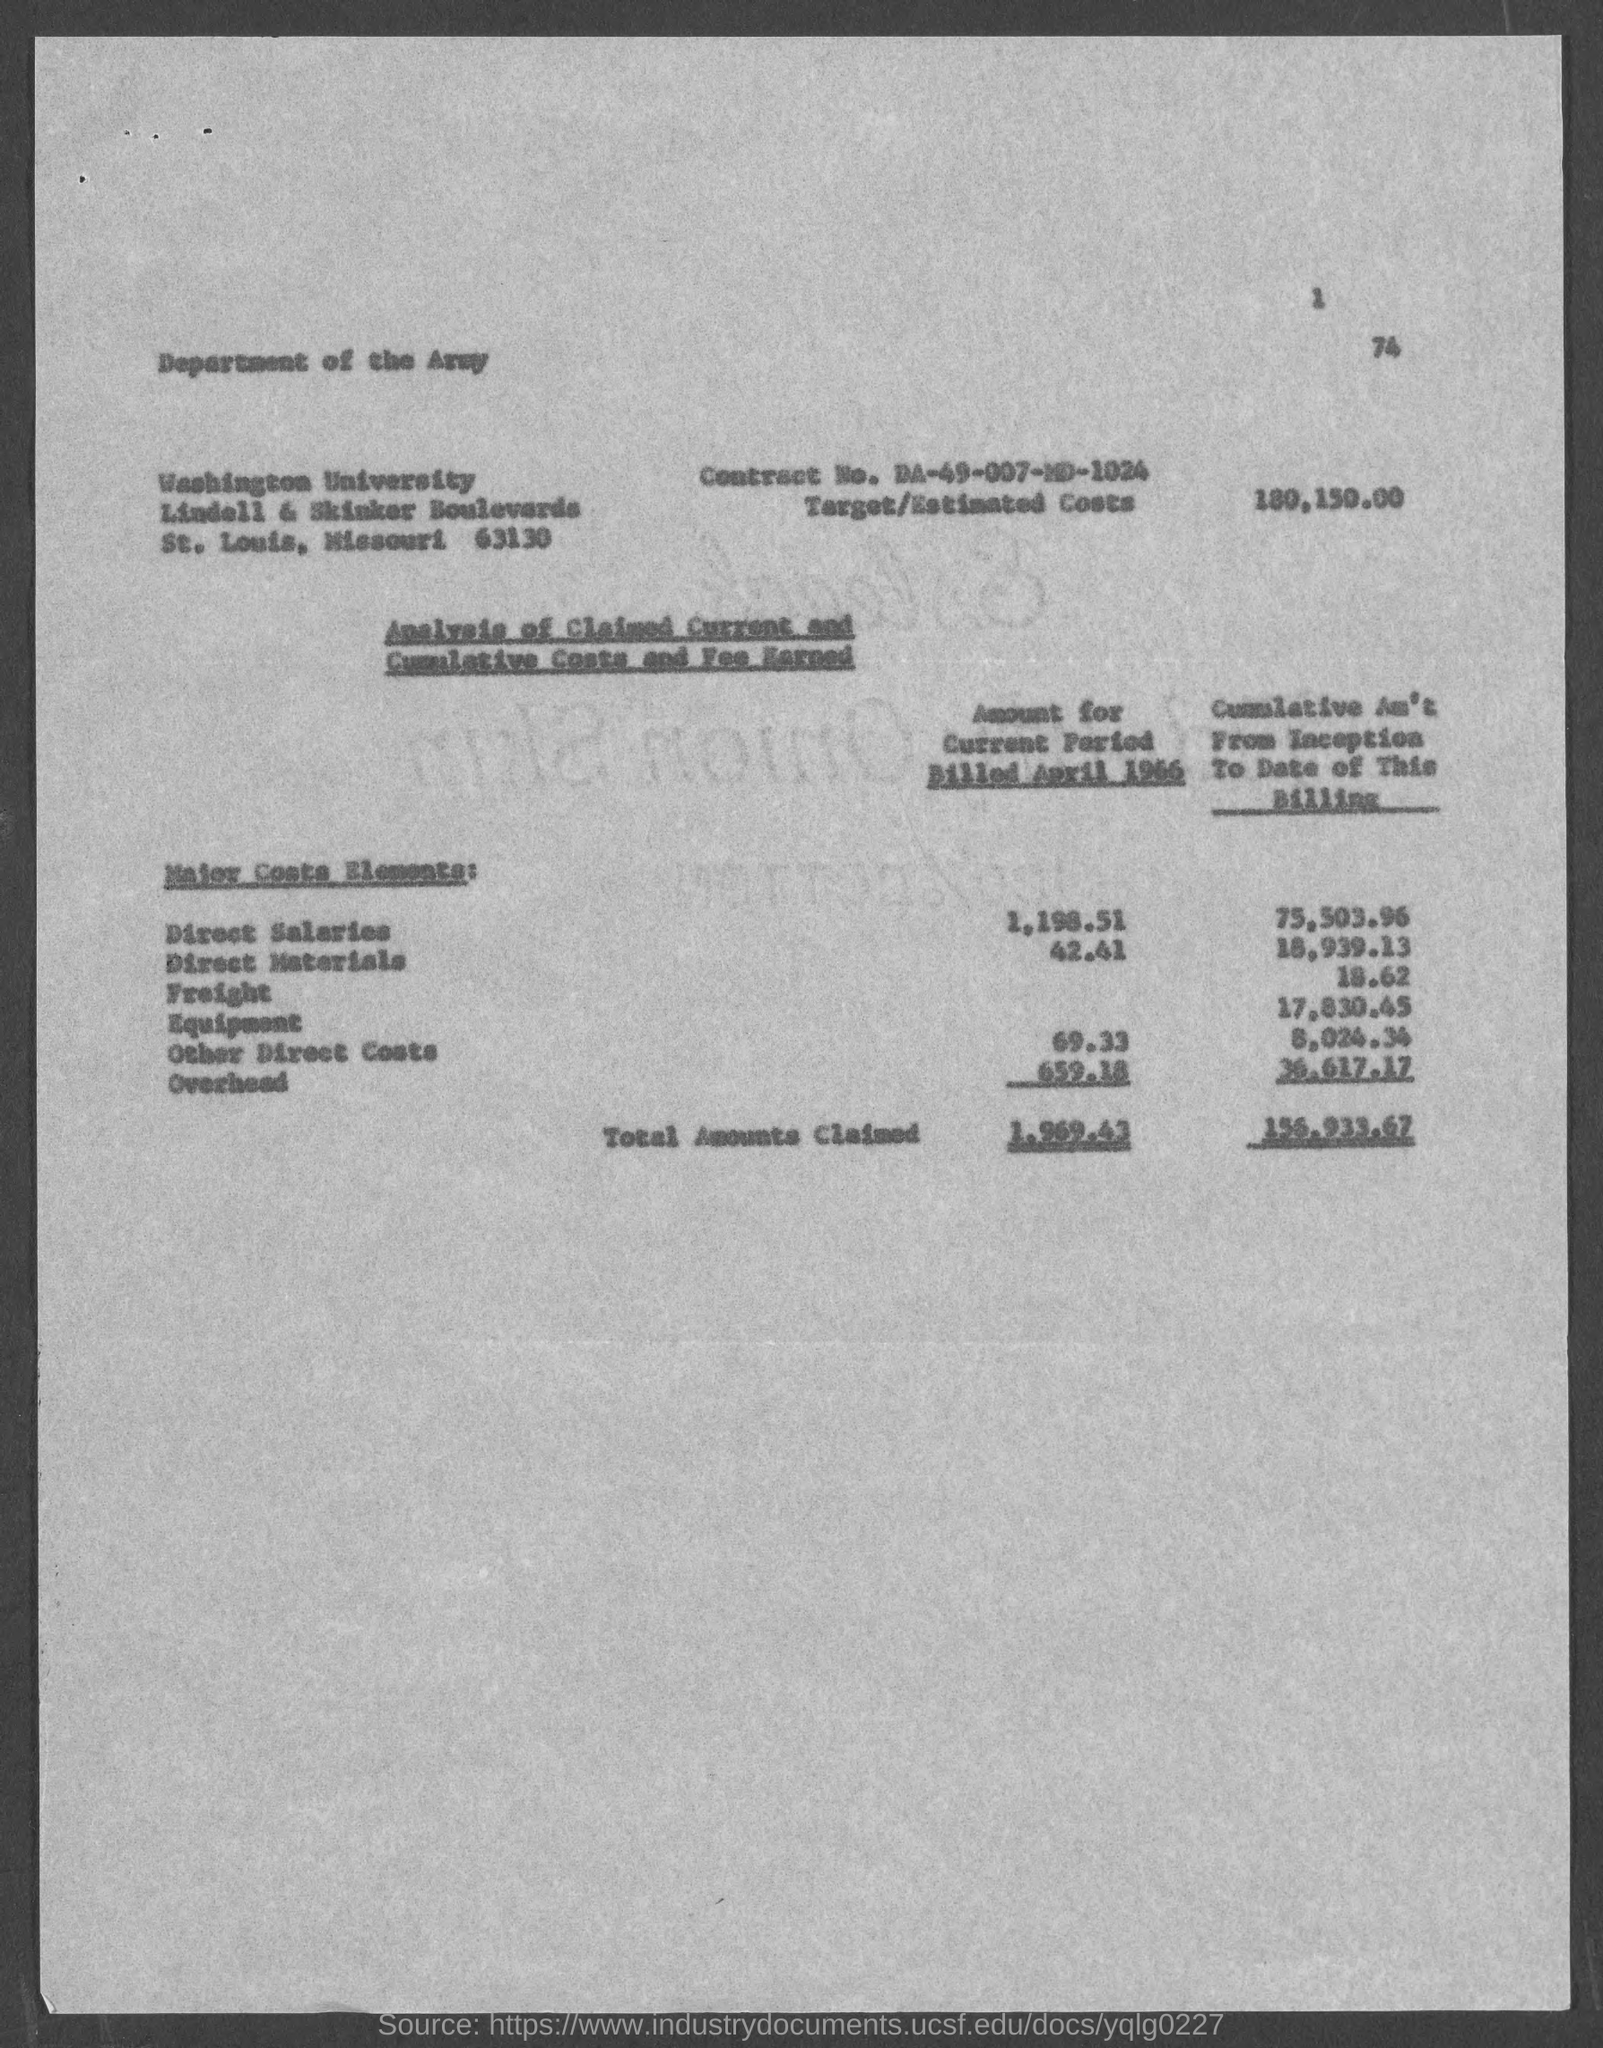Outline some significant characteristics in this image. The page number at the top of the page is 1. The estimated costs for the project are 180,150.00. The contract number is DA-49-007-MD-1024. 